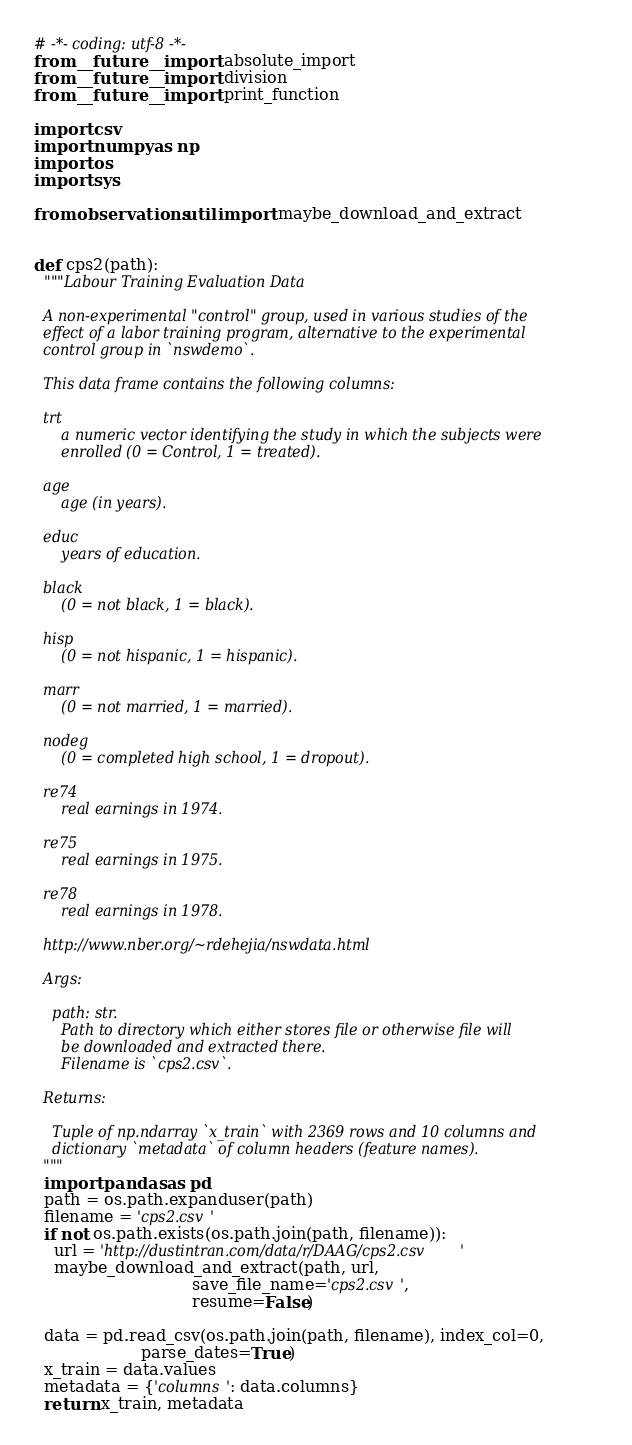Convert code to text. <code><loc_0><loc_0><loc_500><loc_500><_Python_># -*- coding: utf-8 -*-
from __future__ import absolute_import
from __future__ import division
from __future__ import print_function

import csv
import numpy as np
import os
import sys

from observations.util import maybe_download_and_extract


def cps2(path):
  """Labour Training Evaluation Data

  A non-experimental "control" group, used in various studies of the
  effect of a labor training program, alternative to the experimental
  control group in `nswdemo`.

  This data frame contains the following columns:

  trt
      a numeric vector identifying the study in which the subjects were
      enrolled (0 = Control, 1 = treated).

  age
      age (in years).

  educ
      years of education.

  black
      (0 = not black, 1 = black).

  hisp
      (0 = not hispanic, 1 = hispanic).

  marr
      (0 = not married, 1 = married).

  nodeg
      (0 = completed high school, 1 = dropout).

  re74
      real earnings in 1974.

  re75
      real earnings in 1975.

  re78
      real earnings in 1978.

  http://www.nber.org/~rdehejia/nswdata.html

  Args:

    path: str.
      Path to directory which either stores file or otherwise file will
      be downloaded and extracted there.
      Filename is `cps2.csv`.

  Returns:

    Tuple of np.ndarray `x_train` with 2369 rows and 10 columns and
    dictionary `metadata` of column headers (feature names).
  """
  import pandas as pd
  path = os.path.expanduser(path)
  filename = 'cps2.csv'
  if not os.path.exists(os.path.join(path, filename)):
    url = 'http://dustintran.com/data/r/DAAG/cps2.csv'
    maybe_download_and_extract(path, url,
                               save_file_name='cps2.csv',
                               resume=False)

  data = pd.read_csv(os.path.join(path, filename), index_col=0,
                     parse_dates=True)
  x_train = data.values
  metadata = {'columns': data.columns}
  return x_train, metadata
</code> 